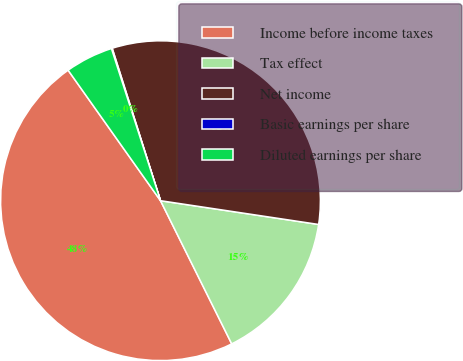<chart> <loc_0><loc_0><loc_500><loc_500><pie_chart><fcel>Income before income taxes<fcel>Tax effect<fcel>Net income<fcel>Basic earnings per share<fcel>Diluted earnings per share<nl><fcel>47.54%<fcel>15.28%<fcel>32.26%<fcel>0.08%<fcel>4.84%<nl></chart> 